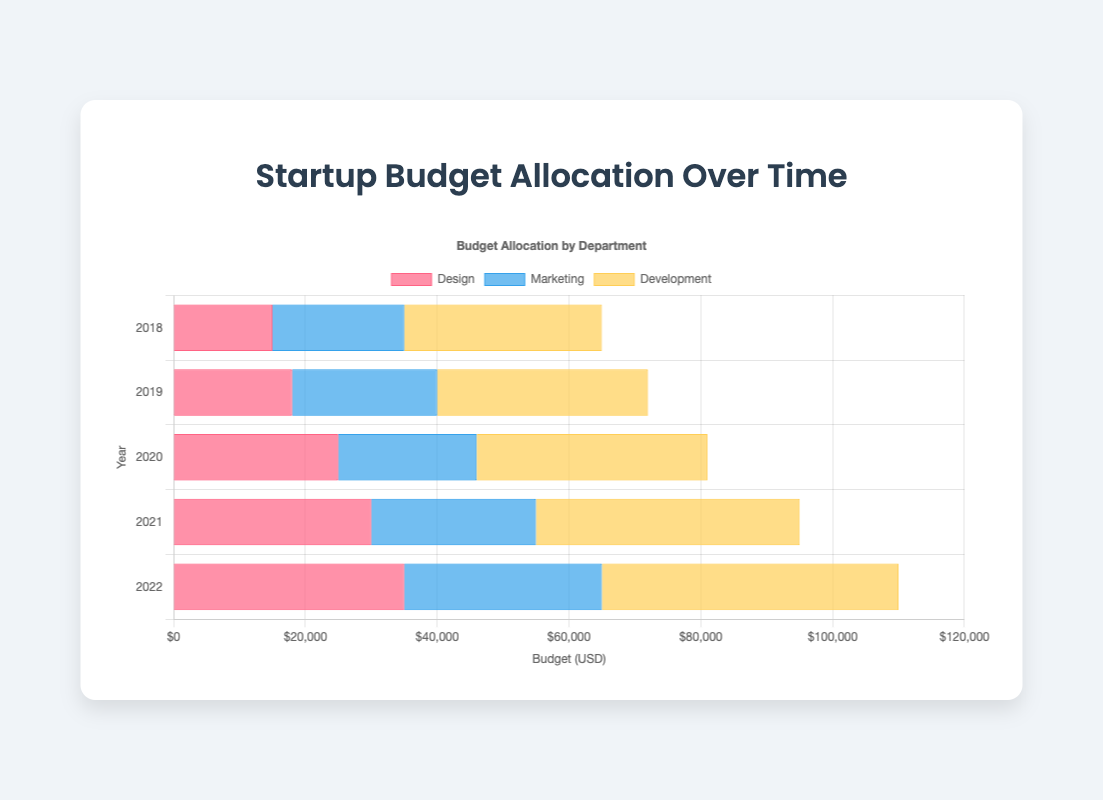Which department had the highest total budget allocation in 2022? Look at the 2022 horizontal bars for each department. The "Development" department had the longest bar, indicating the highest budget.
Answer: Development How much more budget was allocated to Development than Design in 2019? Subtract the Design budget from the Development budget in 2019. Development had 32,000 and Design had 18,000. So, 32,000 - 18,000 = 14,000.
Answer: 14,000 What was the average budget allocation for Marketing from 2018 to 2022? Add the yearly budgets for Marketing and divide by the number of years. (20,000 + 22,000 + 21,000 + 25,000 + 30,000) / 5 = 118,000 / 5.
Answer: 23,600 Which year saw the largest budget increase for Design from the previous year? Calculate the yearly increase for Design and identify the largest one. 2019-2018: 18,000-15,000 = 3,000, 2020-2019: 25,000-18,000 = 7,000, 2021-2020: 30,000-25,000 = 5,000, 2022-2021: 35,000-30,000 = 5,000. The largest is from 2019 to 2020.
Answer: 2020 What is the total budget allocated to Marketing and Development combined in 2022? Add the budget for Marketing and Development in 2022. Marketing: 30,000, Development: 45,000. So, 30,000 + 45,000 = 75,000.
Answer: 75,000 How did the Design department's budget allocation in 2021 compare to its allocation in 2020? Calculate the difference between the two years for Design. In 2021 it was 30,000 and in 2020 it was 25,000. 30,000 - 25,000 = 5,000 increase.
Answer: Increased by 5,000 Which department had the smallest budget allocation in 2018? Compare the 2018 budget bars for all departments. Design had the smallest bar with 15,000.
Answer: Design What is the combined total budget allocation for all departments in 2020? Sum the budgets for all departments in 2020. Design: 25,000, Marketing: 21,000, Development: 35,000. So, 25,000 + 21,000 + 35,000 = 81,000.
Answer: 81,000 Which department showed the least variability in its yearly budget allocation from 2018 to 2022? Examine the bars for each department over the years; Marketing shows the least change, ranging between 20,000 to 30,000.
Answer: Marketing 